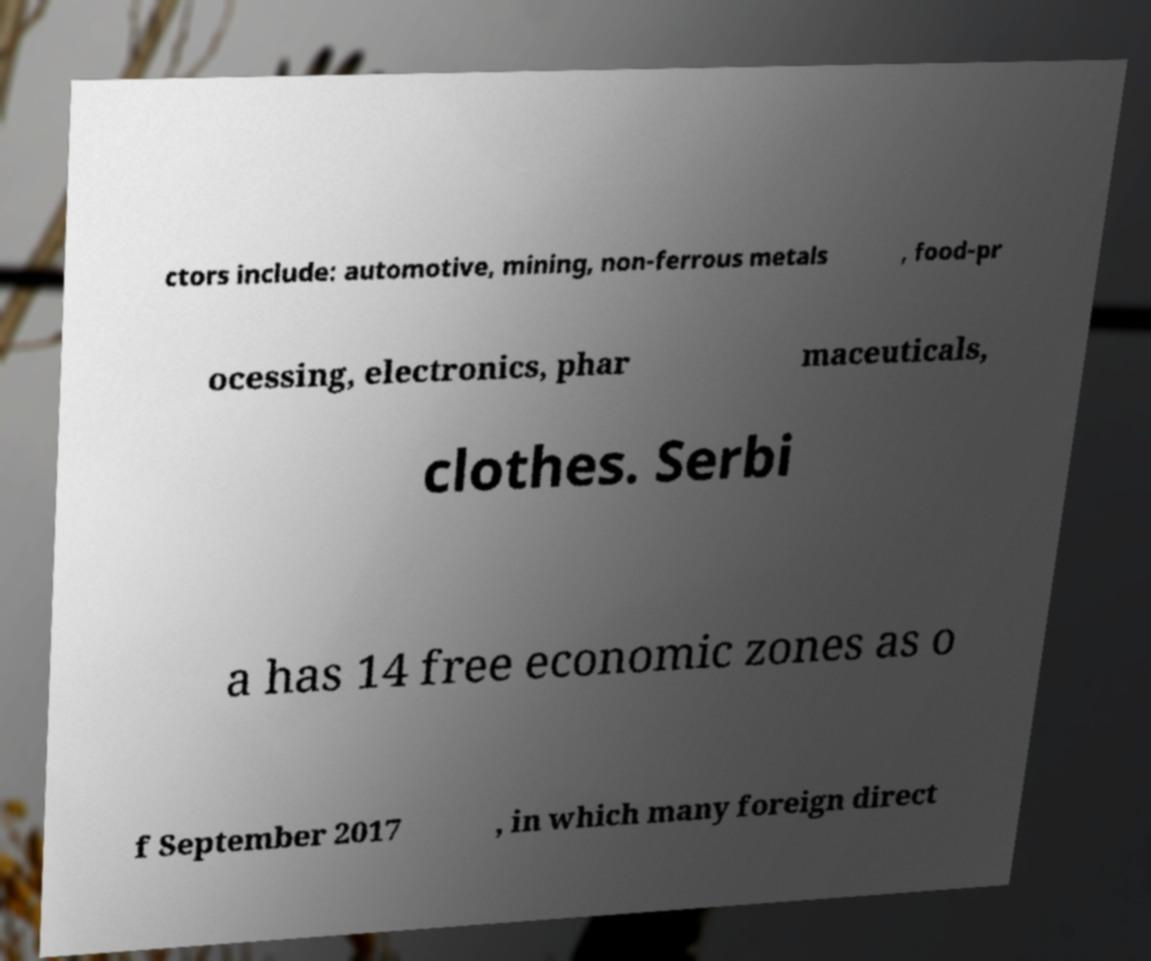There's text embedded in this image that I need extracted. Can you transcribe it verbatim? ctors include: automotive, mining, non-ferrous metals , food-pr ocessing, electronics, phar maceuticals, clothes. Serbi a has 14 free economic zones as o f September 2017 , in which many foreign direct 